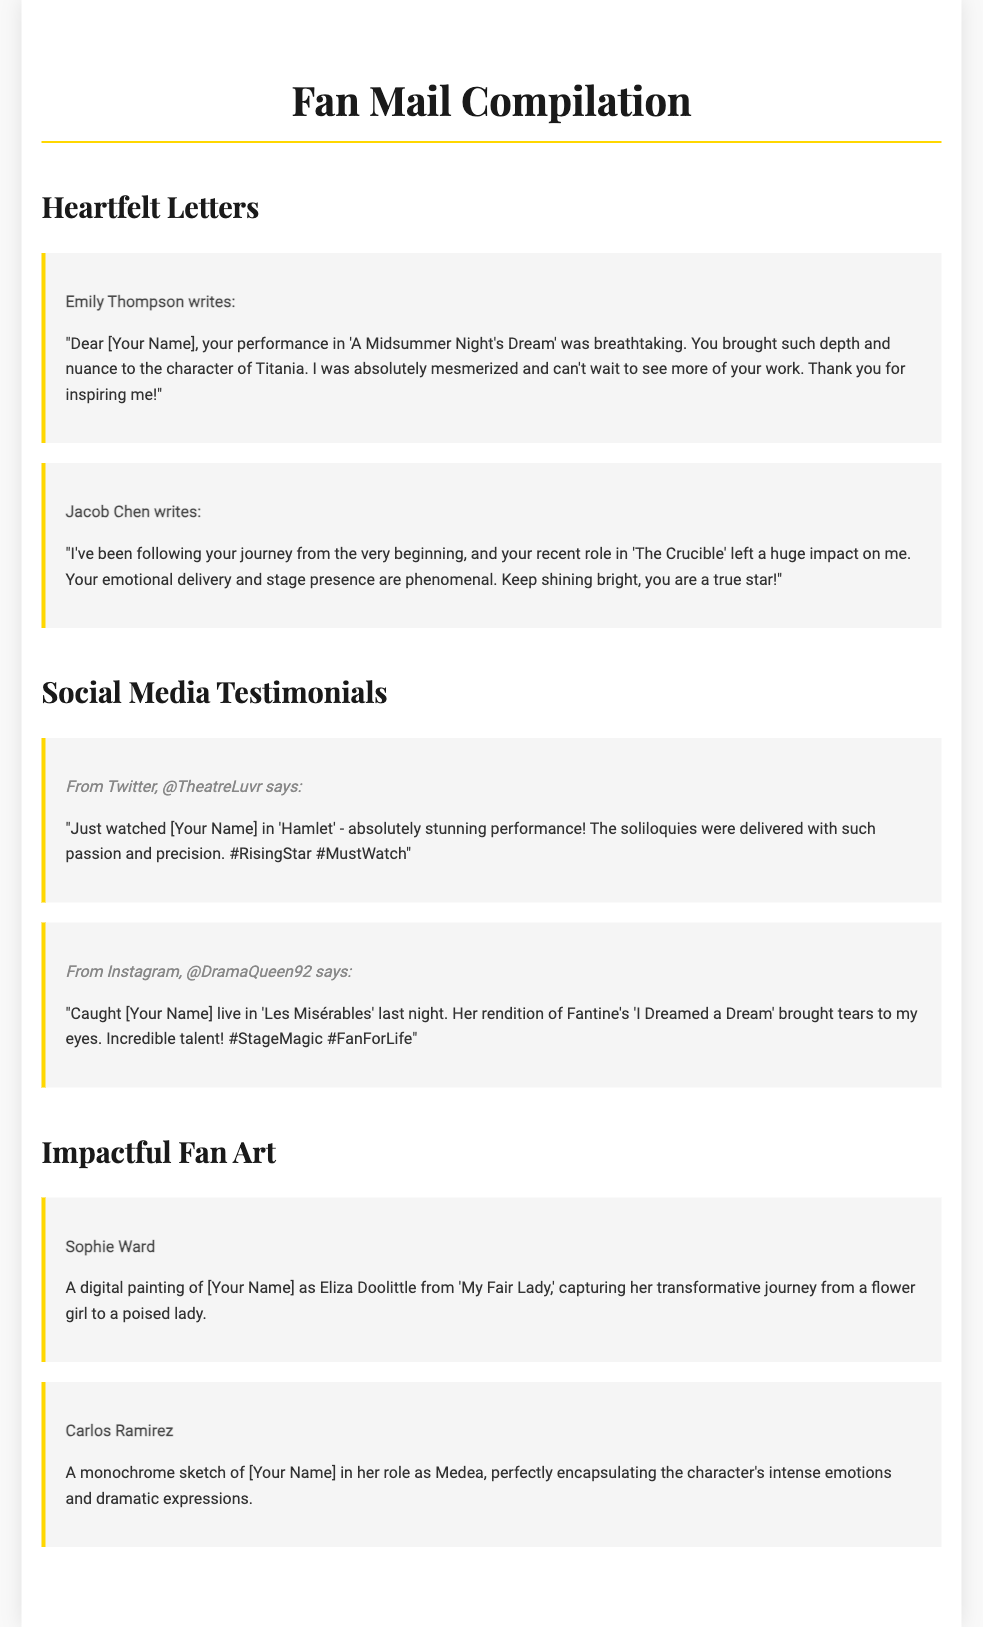What is the title of the document? The title of the document is presented in the header section where it states "Fan Mail Compilation."
Answer: Fan Mail Compilation Who wrote the letter praising the performance in 'A Midsummer Night's Dream'? The letter expressing admiration for 'A Midsummer Night's Dream' was written by Emily Thompson.
Answer: Emily Thompson Which social media platform mentioned a stunning performance in 'Hamlet'? The social media platform where a stunning performance in 'Hamlet' was mentioned is Twitter.
Answer: Twitter How many heartfelt letters are included in the document? The document features a total of two heartfelt letters, which are displayed in the Heartfelt Letters section.
Answer: 2 What did Sophie Ward create? Sophie Ward created a digital painting of [Your Name] as Eliza Doolittle from 'My Fair Lady.'
Answer: A digital painting What is the color of the border in the letter and testimonial sections? The color of the border in both the letter and testimonial sections is defined as a shade of gold, specifically #ffd700.
Answer: Gold Which character did [Your Name] play in 'Les Misérables'? In 'Les Misérables,' [Your Name] portrayed the character Fantine as mentioned in the social media testimonial.
Answer: Fantine Who expressed that [Your Name] is a true star? Jacob Chen expressed that [Your Name] is a true star in one of the heartfelt letters.
Answer: Jacob Chen 